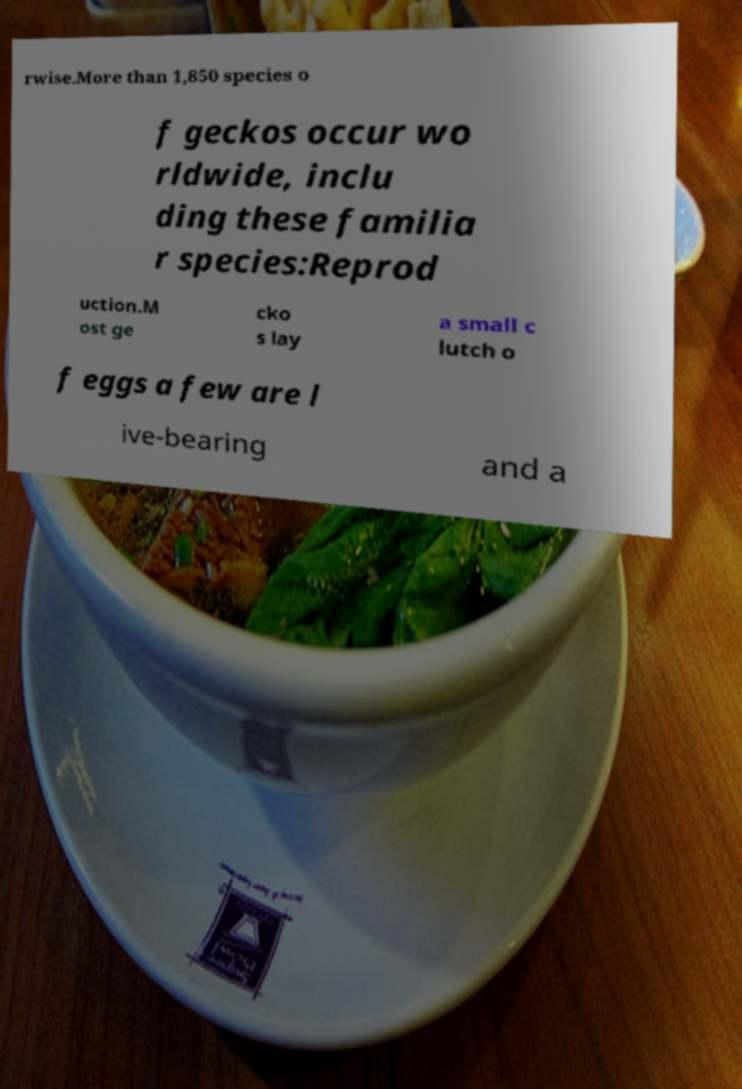For documentation purposes, I need the text within this image transcribed. Could you provide that? rwise.More than 1,850 species o f geckos occur wo rldwide, inclu ding these familia r species:Reprod uction.M ost ge cko s lay a small c lutch o f eggs a few are l ive-bearing and a 